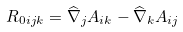<formula> <loc_0><loc_0><loc_500><loc_500>R _ { 0 i j k } = \widehat { \nabla } _ { j } A _ { i k } - \widehat { \nabla } _ { k } A _ { i j }</formula> 